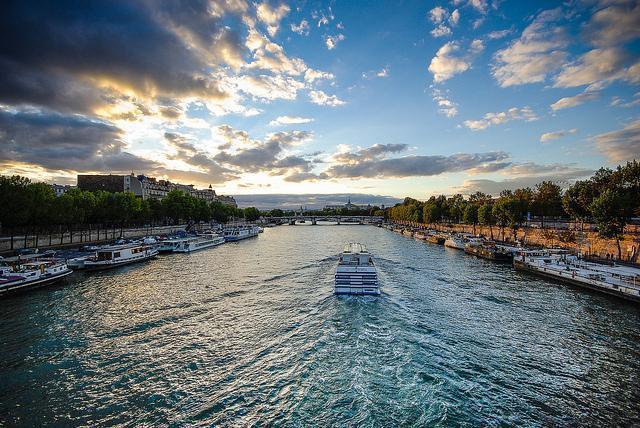What is creating the larger waves?
Choose the right answer and clarify with the format: 'Answer: answer
Rationale: rationale.'
Options: Wind, kids, falling objects, boat. Answer: boat.
Rationale: There is a moving vehicle in the otherwise calm water. there are no kids or falling objects. 